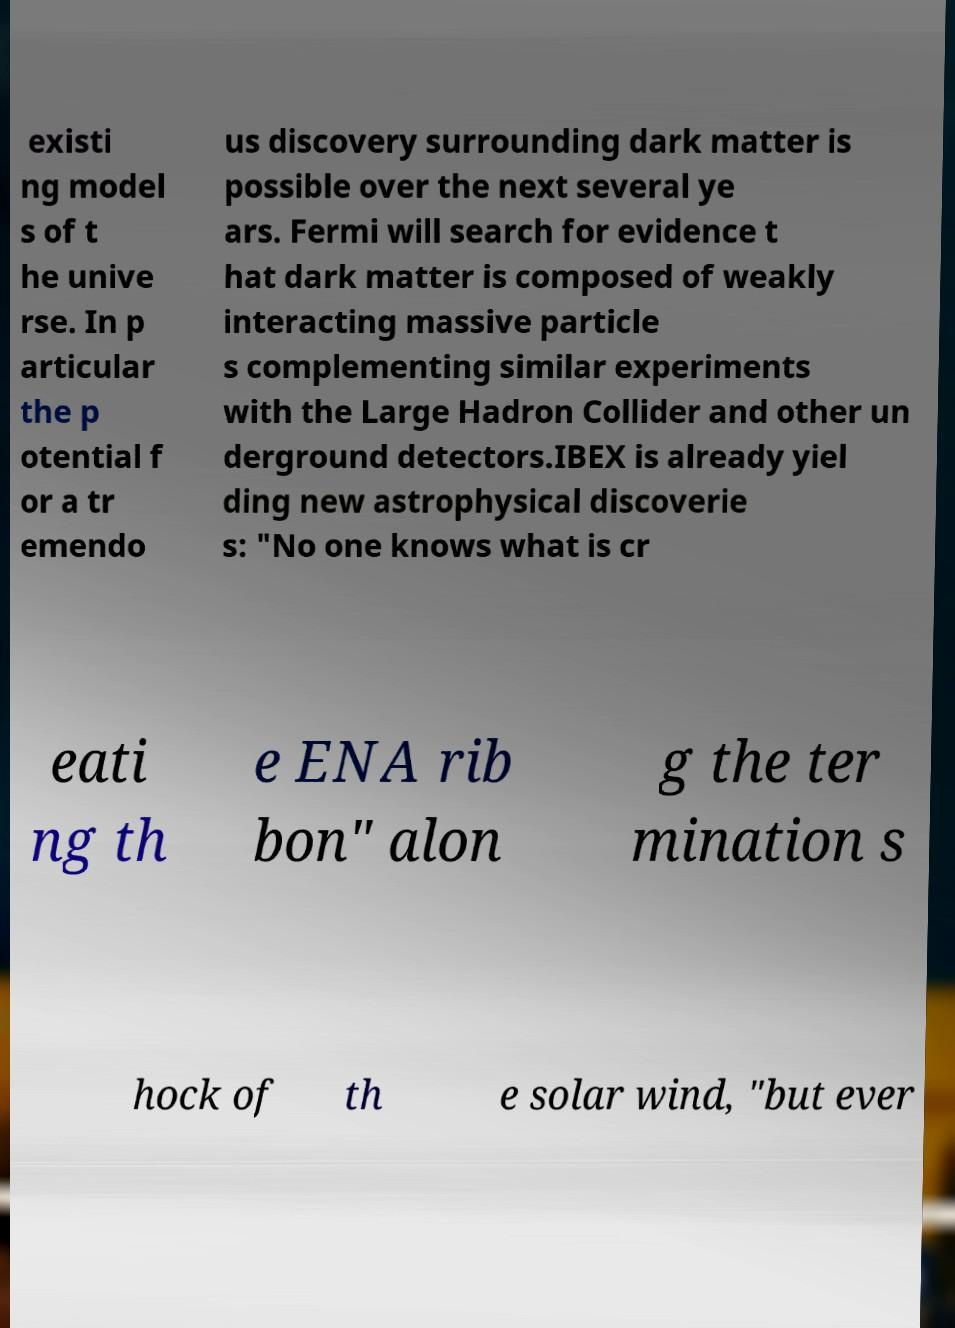Please identify and transcribe the text found in this image. existi ng model s of t he unive rse. In p articular the p otential f or a tr emendo us discovery surrounding dark matter is possible over the next several ye ars. Fermi will search for evidence t hat dark matter is composed of weakly interacting massive particle s complementing similar experiments with the Large Hadron Collider and other un derground detectors.IBEX is already yiel ding new astrophysical discoverie s: "No one knows what is cr eati ng th e ENA rib bon" alon g the ter mination s hock of th e solar wind, "but ever 